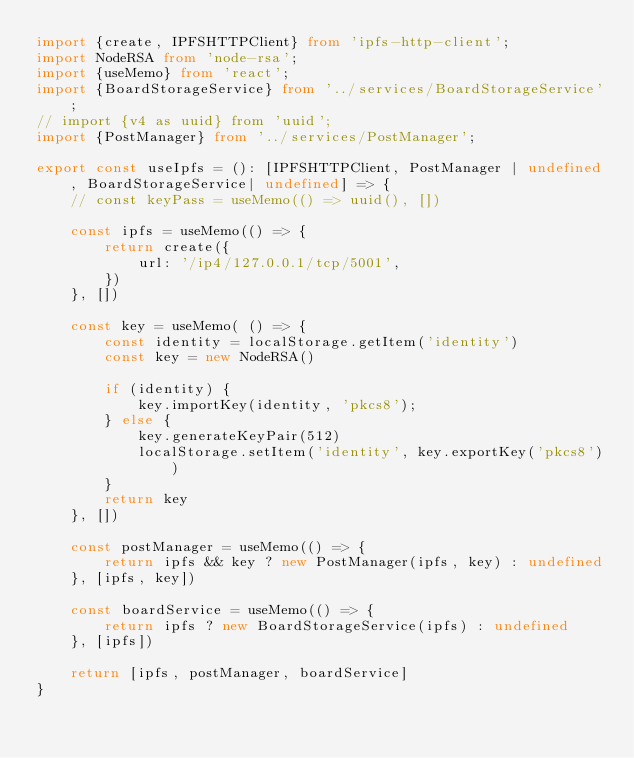Convert code to text. <code><loc_0><loc_0><loc_500><loc_500><_TypeScript_>import {create, IPFSHTTPClient} from 'ipfs-http-client';
import NodeRSA from 'node-rsa';
import {useMemo} from 'react';
import {BoardStorageService} from '../services/BoardStorageService';
// import {v4 as uuid} from 'uuid';
import {PostManager} from '../services/PostManager';

export const useIpfs = (): [IPFSHTTPClient, PostManager | undefined, BoardStorageService| undefined] => {
	// const keyPass = useMemo(() => uuid(), [])

	const ipfs = useMemo(() => {
		return create({
			url: '/ip4/127.0.0.1/tcp/5001',
		})
	}, [])

	const key = useMemo( () => {
		const identity = localStorage.getItem('identity')
		const key = new NodeRSA()

		if (identity) {
			key.importKey(identity, 'pkcs8');
		} else {
			key.generateKeyPair(512)
			localStorage.setItem('identity', key.exportKey('pkcs8'))
		}
		return key
	}, [])

	const postManager = useMemo(() => {
		return ipfs && key ? new PostManager(ipfs, key) : undefined
	}, [ipfs, key])

	const boardService = useMemo(() => {
		return ipfs ? new BoardStorageService(ipfs) : undefined
	}, [ipfs])

	return [ipfs, postManager, boardService]
}
</code> 